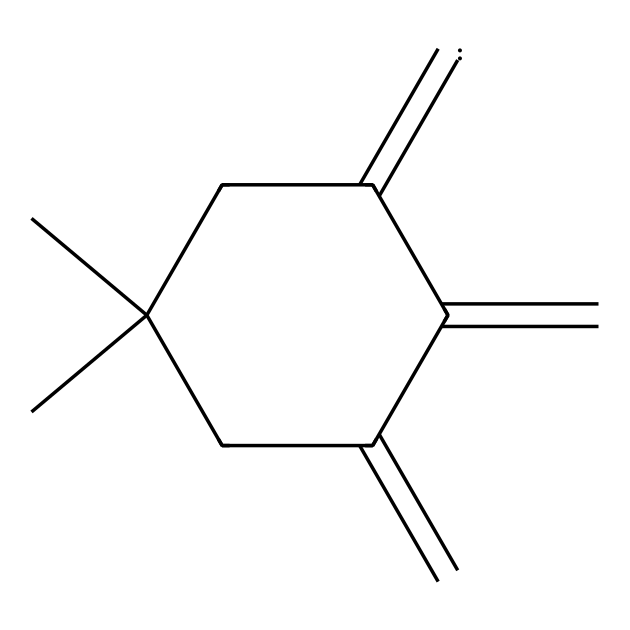What is the connectivity of carbon atoms in this molecule? The chemical structure shows a cycloalkene with a double bond and multiple branching, indicating a total of ten carbon atoms connected by single and double bonds.
Answer: ten How many double bonds are present in the chemical structure? Examining the structure reveals one double bond within the cycloalkene ring and one connecting to a substituent, leading to a total of two double bonds.
Answer: two What type of carbene is involved in this chemical structure? The structure includes a diene where a carbenic species may arise from the breaking and reforming of a double bond, suggesting that an electrophilic carbene is likely present.
Answer: electrophilic In what type of reaction might this carbene intermediate be involved during synthesis? The carbene's reactivity typically suggests participation in cyclopropanation, which involves forming a three-membered ring during the synthesis process.
Answer: cyclopropanation What is the possible role of the carbene in generating fragrance molecules? Carbenes can facilitate the formation of complex cyclic structures, leading to unique aromatic compounds that contribute to the bluebonnet fragrance profile.
Answer: aromatic compounds Which functional group is implied by the structure's carbon connectivity? The connectivity suggests the presence of an alkene functional group due to the double bonds present within the structure, confirmed by visual inspection of the carbon arrangements.
Answer: alkene 